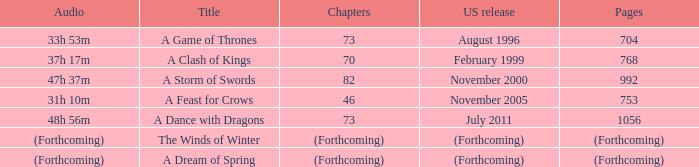Which title has a US release of august 1996? A Game of Thrones. 